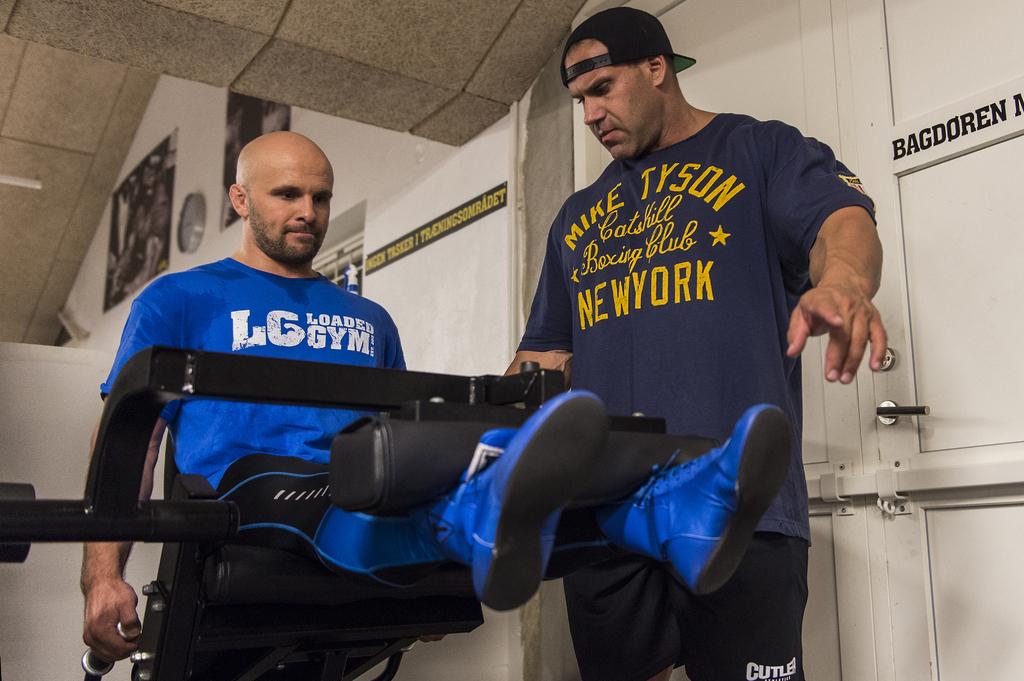What is the name of the gym?
Ensure brevity in your answer.  Lg. Where is this man at?
Offer a terse response. New york. 